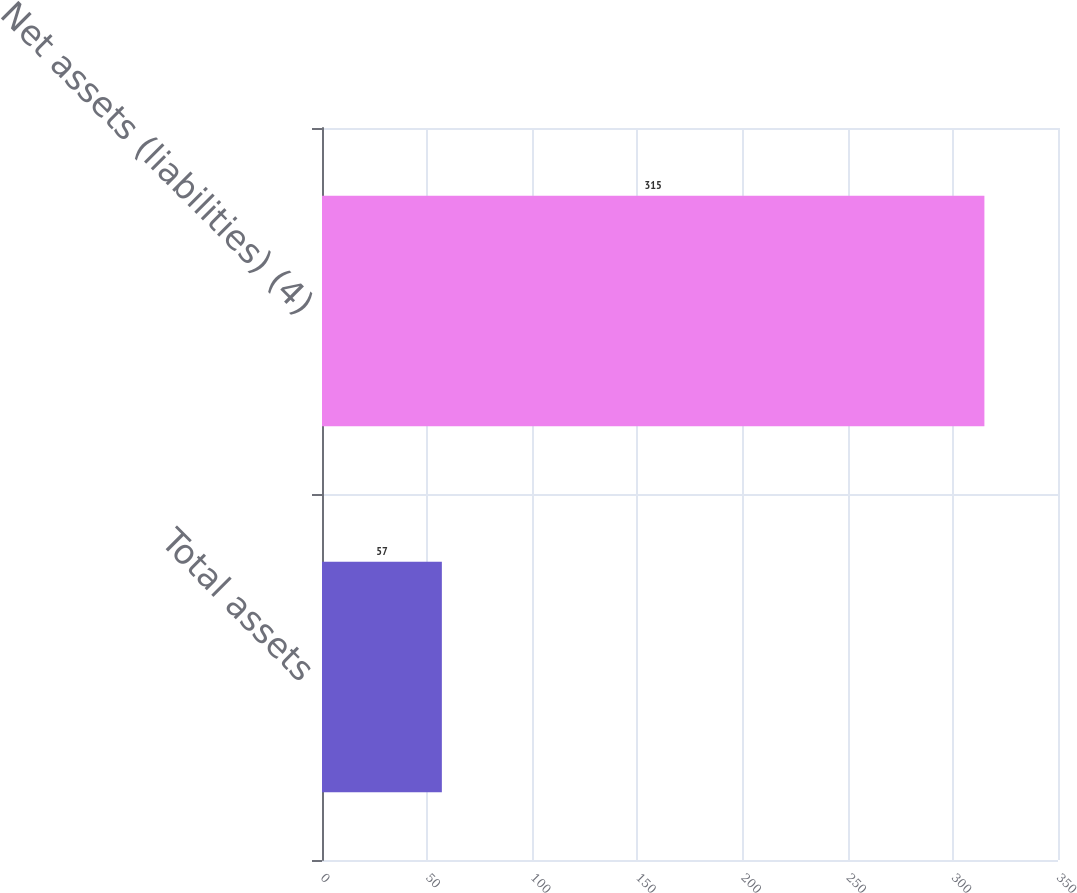<chart> <loc_0><loc_0><loc_500><loc_500><bar_chart><fcel>Total assets<fcel>Net assets (liabilities) (4)<nl><fcel>57<fcel>315<nl></chart> 